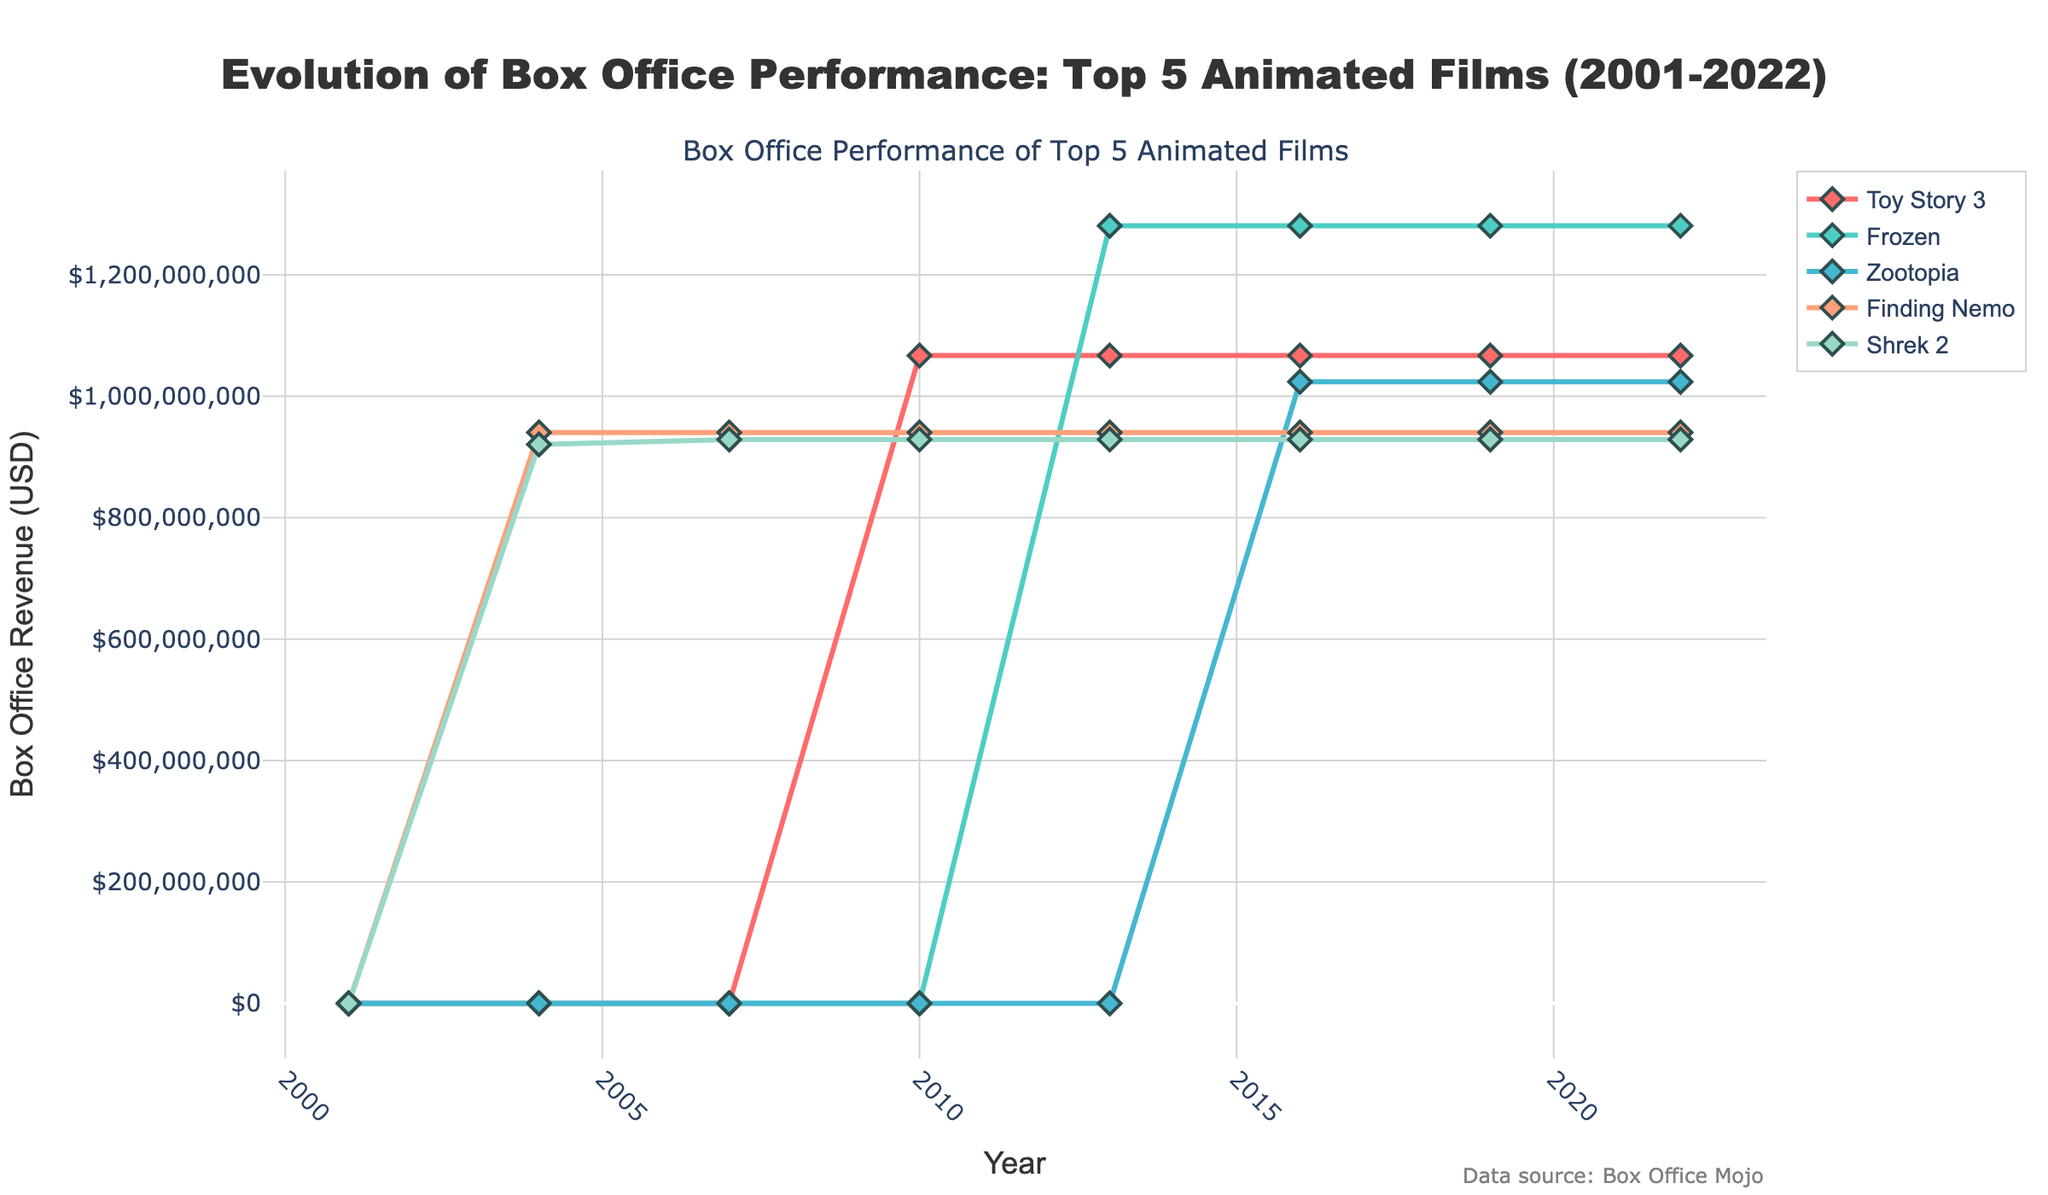What's the total box office revenue for "Frozen" from 2010 to 2022? To find the total box office revenue for "Frozen" from 2010 to 2022, we sum the revenue values for each year listed in the figure: 0 (2010) + 1280802282 (2013) + 1280802282 (2016) + 1280802282 (2019) + 1280802282 (2022) = 6404011410 USD.
Answer: 6404011410 USD Which film achieved the highest box office revenue overall? The highest box office revenue can be identified by looking at each film's peak value in the figure. The highest value shown is 1280802282 USD for "Frozen".
Answer: Frozen Between "Toy Story 3" and "Shrek 2", which film had a more stable box office revenue over the years? "Shrek 2" maintained a consistent revenue from 2007 to 2022, while "Toy Story 3" shows an increase only from 2010 onwards. Therefore, "Shrek 2" had a more stable box office revenue.
Answer: Shrek 2 In which year did "Zootopia" overtake "Finding Nemo" in box office revenue? "Zootopia" first appears with revenue in 2016 and directly surpasses "Finding Nemo", which had a consistent revenue since 2004. Therefore, "Zootopia" overtakes "Finding Nemo" in 2016.
Answer: 2016 Which film shows revenue data starting the latest? "Zootopia" shows revenue starting from 2016, which is later than the other films in the figure.
Answer: Zootopia By how much did "Shrek 2" outgross "Finding Nemo" in 2007? In 2007, "Shrek 2" had revenue of 928760770 USD and "Finding Nemo" had revenue of 940335536 USD. The difference is 940335536 - 928760770 = 11574766 USD. Therefore, "Finding Nemo" outgrossed "Shrek 2" by that amount.
Answer: 11574766 USD What's the average box office revenue of "Toy Story 3" between 2010 and 2022? To find the average box office revenue for "Toy Story 3" between 2010 and 2022 inclusive, sum the values from each year and divide by the number of years it was released. Summing up: 1066969703 (2010) + 1066969703 (2013) + 1066969703 (2016) + 1066969703 (2019) + 1066969703 (2022) = 5334848515; dividing this sum by 5 years gives 5334848515 / 5 = 1066969703 USD.
Answer: 1066969703 USD How many times did "Frozen" appear in the figure? "Frozen" appears in the years 2013, 2016, 2019, and 2022, making a total of 4 appearances.
Answer: 4 